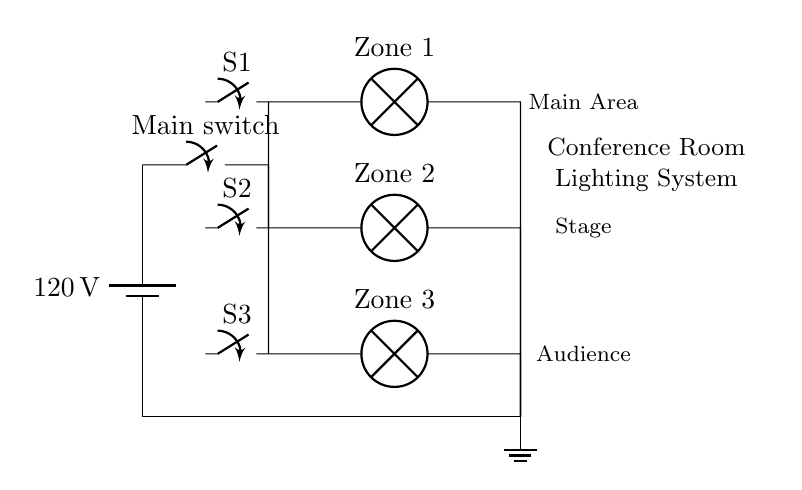What is the voltage across the lamps? The voltage across the lamps is 120 volts, as they are connected in parallel to the main power source, which provides this voltage.
Answer: 120 volts How many zones of lighting does the circuit include? The circuit includes three zones of lighting, as indicated by the three separate lamps each labeled as Zone 1, Zone 2, and Zone 3.
Answer: Three What is the purpose of the main switch? The main switch serves as a control mechanism to turn the entire lighting system on or off, impacting all branches simultaneously since they are in parallel.
Answer: Control mechanism Which component allows for individual control of each lighting zone? Each lighting zone has its own individual switch (S1, S2, S3) that allows for independent operation of that specific lamp.
Answer: Individual switches What type of circuit configuration is used in this lighting system? The lighting system uses a parallel circuit configuration, where each lamp operates independently and is connected across the same voltage source.
Answer: Parallel circuit If one lamp fails, what happens to the others? If one lamp fails, the others remain operational because the lamps are connected in parallel, allowing current to flow through alternate paths.
Answer: Remain operational 